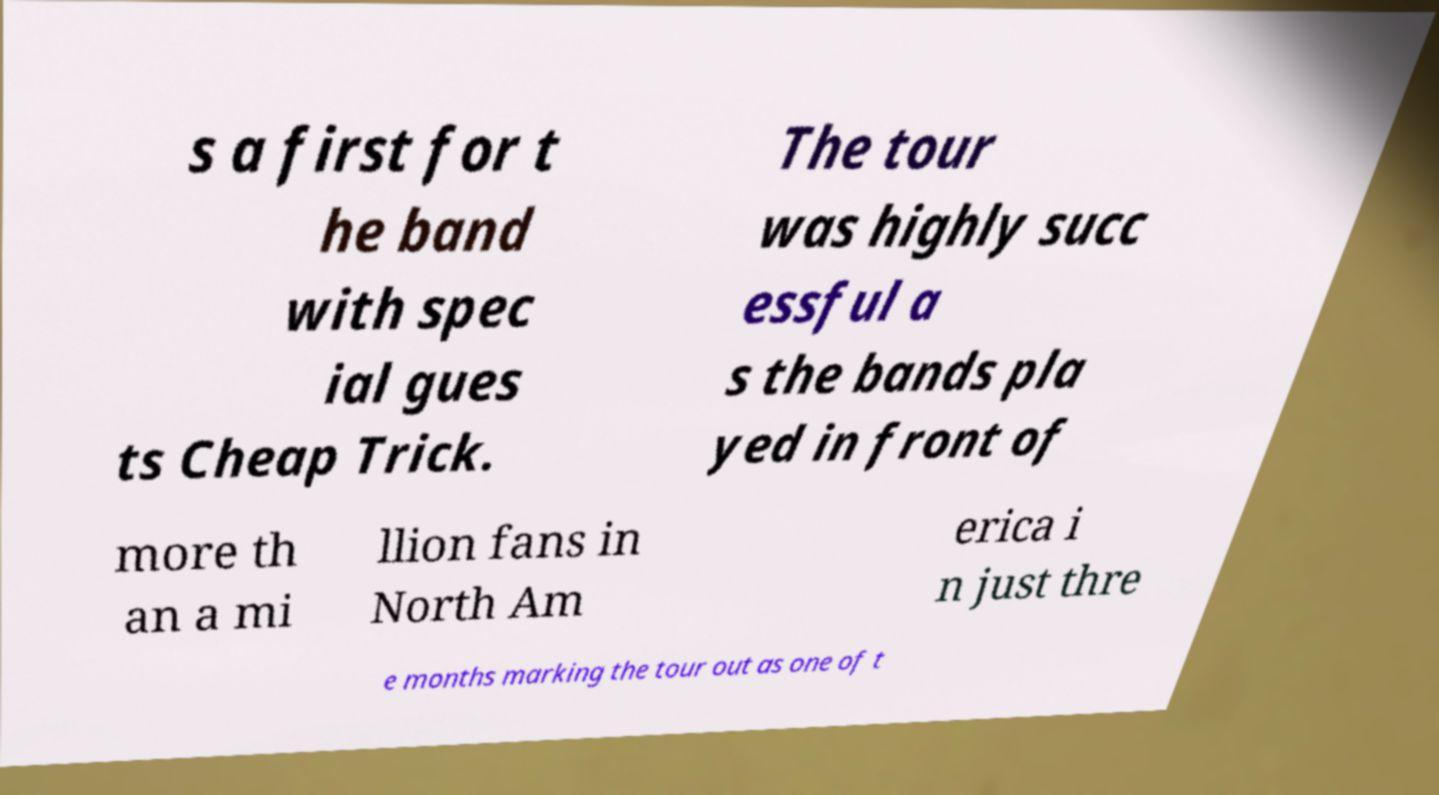There's text embedded in this image that I need extracted. Can you transcribe it verbatim? s a first for t he band with spec ial gues ts Cheap Trick. The tour was highly succ essful a s the bands pla yed in front of more th an a mi llion fans in North Am erica i n just thre e months marking the tour out as one of t 